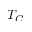Convert formula to latex. <formula><loc_0><loc_0><loc_500><loc_500>T _ { C }</formula> 